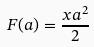Convert formula to latex. <formula><loc_0><loc_0><loc_500><loc_500>F ( a ) = \frac { x a ^ { 2 } } { 2 }</formula> 